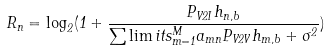Convert formula to latex. <formula><loc_0><loc_0><loc_500><loc_500>R _ { n } = { \log _ { 2 } } ( 1 + \frac { { { P _ { V 2 I } } { h _ { n , b } } } } { { \sum \lim i t s _ { m = 1 } ^ { M } { { a _ { m n } } { P _ { V 2 V } } { h _ { m , b } } + { \sigma ^ { 2 } } } } } )</formula> 